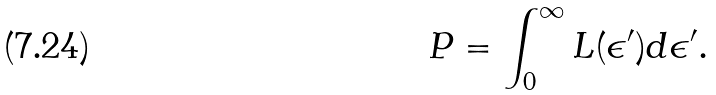Convert formula to latex. <formula><loc_0><loc_0><loc_500><loc_500>P = \int \nolimits _ { 0 } ^ { \infty } L ( \epsilon ^ { \prime } ) d \epsilon ^ { \prime } .</formula> 